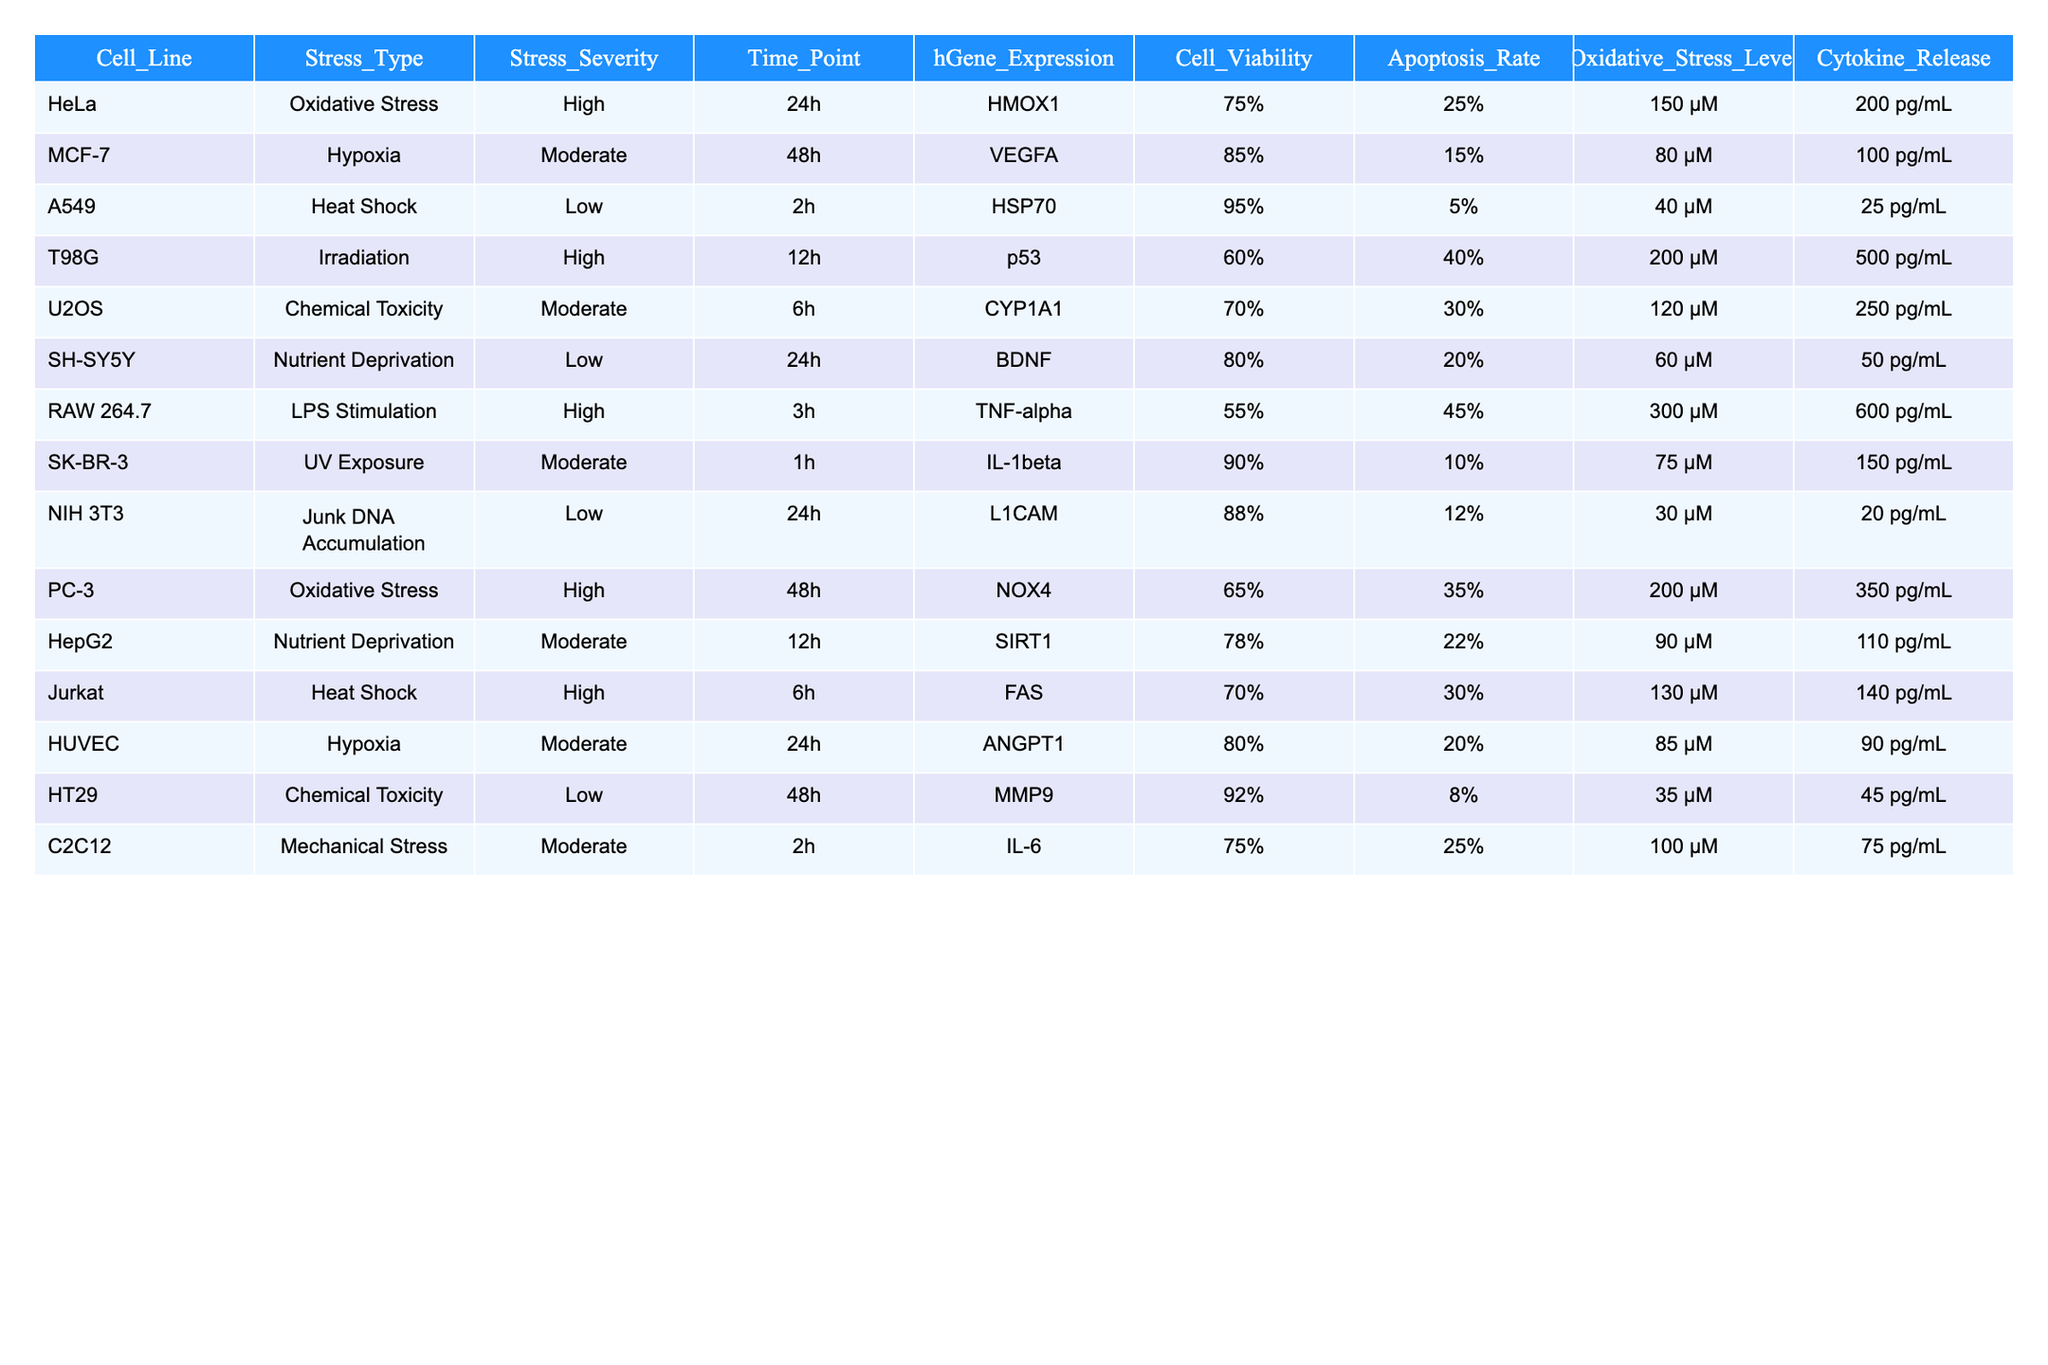What is the cell viability percentage for the HeLa cell line under oxidative stress? The table shows that the HeLa cell line has a cell viability percentage of 75% after exposure to high oxidative stress for 24 hours.
Answer: 75% Which cell line has the highest apoptosis rate and what is that rate? By looking at the table, the RAW 264.7 cell line has the highest apoptosis rate of 45% following high LPS stimulation for 3 hours.
Answer: 45% How many cell lines have reported oxidative stress as a stress type? The data shows that there are three cell lines (HeLa, PC-3, and A549) that report oxidative stress.
Answer: 3 What is the average oxidative stress level for cell lines exposed to high stress severity? Calculating the oxidative stress levels for HeLa (150 µM), T98G (200 µM), RAW 264.7 (300 µM), and PC-3 (200 µM), we have a sum of 850 µM and since there are four data points, the average is 850/4 = 212.5 µM.
Answer: 212.5 µM Is there any cell line that has both high stress severity and low cell viability? Yes, the T98G cell line shows high stress severity from irradiation and has a low cell viability of 60%.
Answer: Yes Which stress type has the highest average cytokine release values across all examined cell lines? The cytokine release values for each stress type are averaged: Oxidative stress (275 pg/mL), Hypoxia (95 pg/mL), Heat Shock (140 pg/mL), Irradiation (500 pg/mL), Chemical Toxicity (255 pg/mL), and LPS Stimulation (600 pg/mL). The highest average is from LPS stimulation at 600 pg/mL.
Answer: 600 pg/mL Are there any cell lines that exhibit nutrient deprivation as a stress type? Yes, both SH-SY5Y and HepG2 cell lines exhibit nutrient deprivation with respective cell viability percentages of 80% and 78%.
Answer: Yes What is the difference in cell viability between the MCF-7 cell line under hypoxia and the NIH 3T3 cell line under junk DNA accumulation? The cell viability for MCF-7 is 85% and for NIH 3T3, it is 88%. The difference is 88% - 85% = 3%.
Answer: 3% Which stress type is associated with the lowest cell viability across all tested cell lines? After reviewing the cell viability percentages, the RAW 264.7 cell line with LPS stimulation has the lowest at 55%.
Answer: 55% 